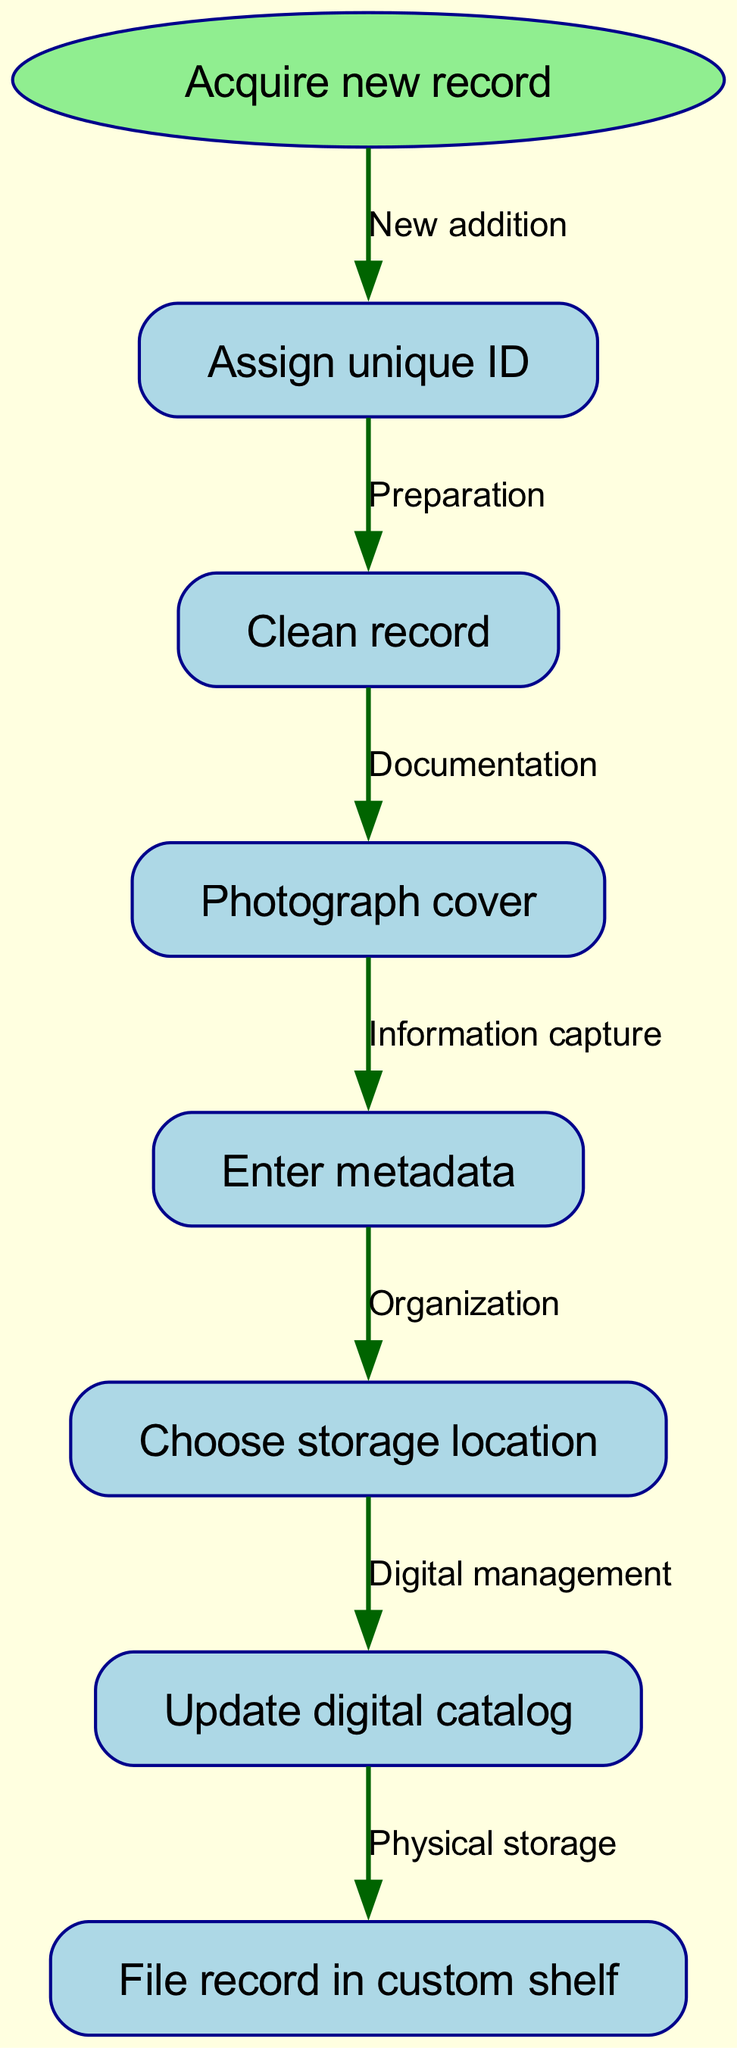What is the first step in the flow chart? The flow chart starts with the node labeled "Acquire new record," which indicates the initial action in the cataloging and organization system.
Answer: Acquire new record How many nodes are in the diagram? To determine the number of nodes, we can count all the unique points within the flow chart, which are: "Acquire new record," "Assign unique ID," "Clean record," "Photograph cover," "Enter metadata," "Choose storage location," "Update digital catalog," and "File record in custom shelf," totaling to 8 nodes.
Answer: 8 What label connects "Clean record" to "Photograph cover"? The edge between "Clean record" and "Photograph cover" is labeled "Documentation," indicating the transition from cleaning to photographing.
Answer: Documentation What action follows "Update digital catalog"? The flow chart shows that after "Update digital catalog," the next action is "File record in custom shelf," indicating the physical storage of the record.
Answer: File record in custom shelf Which node comes immediately after "Enter metadata"? The diagram shows that "Choose storage location" is the next node that follows "Enter metadata," making it the immediate successor in the flow process.
Answer: Choose storage location What is the relationship between "Assign unique ID" and "Clean record"? The flow chart illustrates that "Assign unique ID" leads to "Clean record," establishing a direct relationship where the assignment of an ID is a preparatory step for cleaning the record.
Answer: Preparation How many edges are there in the flow chart? Edges represent the connections between nodes. By counting each directed connection, we find that there are a total of 7 edges in the flow chart, each signifying a process connection.
Answer: 7 What is the purpose of the "Photograph cover" step? The step "Photograph cover" serves the purpose of "Information capture," implying it is crucial for documenting the visual aspect of the record.
Answer: Documentation 